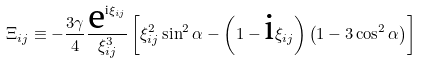<formula> <loc_0><loc_0><loc_500><loc_500>\Xi _ { i j } \equiv - \frac { 3 \gamma } { 4 } \frac { \text {e} ^ { \text {i} \xi _ { i j } } } { \xi _ { i j } ^ { 3 } } \left [ \xi _ { i j } ^ { 2 } \sin ^ { 2 } \alpha - \left ( 1 - \text {i} \xi _ { i j } \right ) \left ( 1 - 3 \cos ^ { 2 } \alpha \right ) \right ]</formula> 